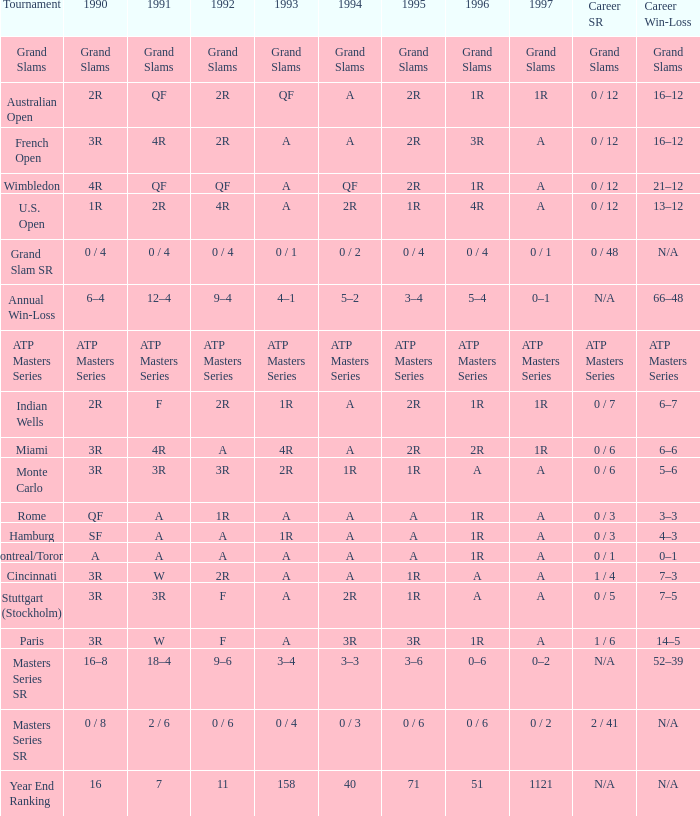What is 1994, when 1991 is "QF", and when Tournament is "Australian Open"? A. 